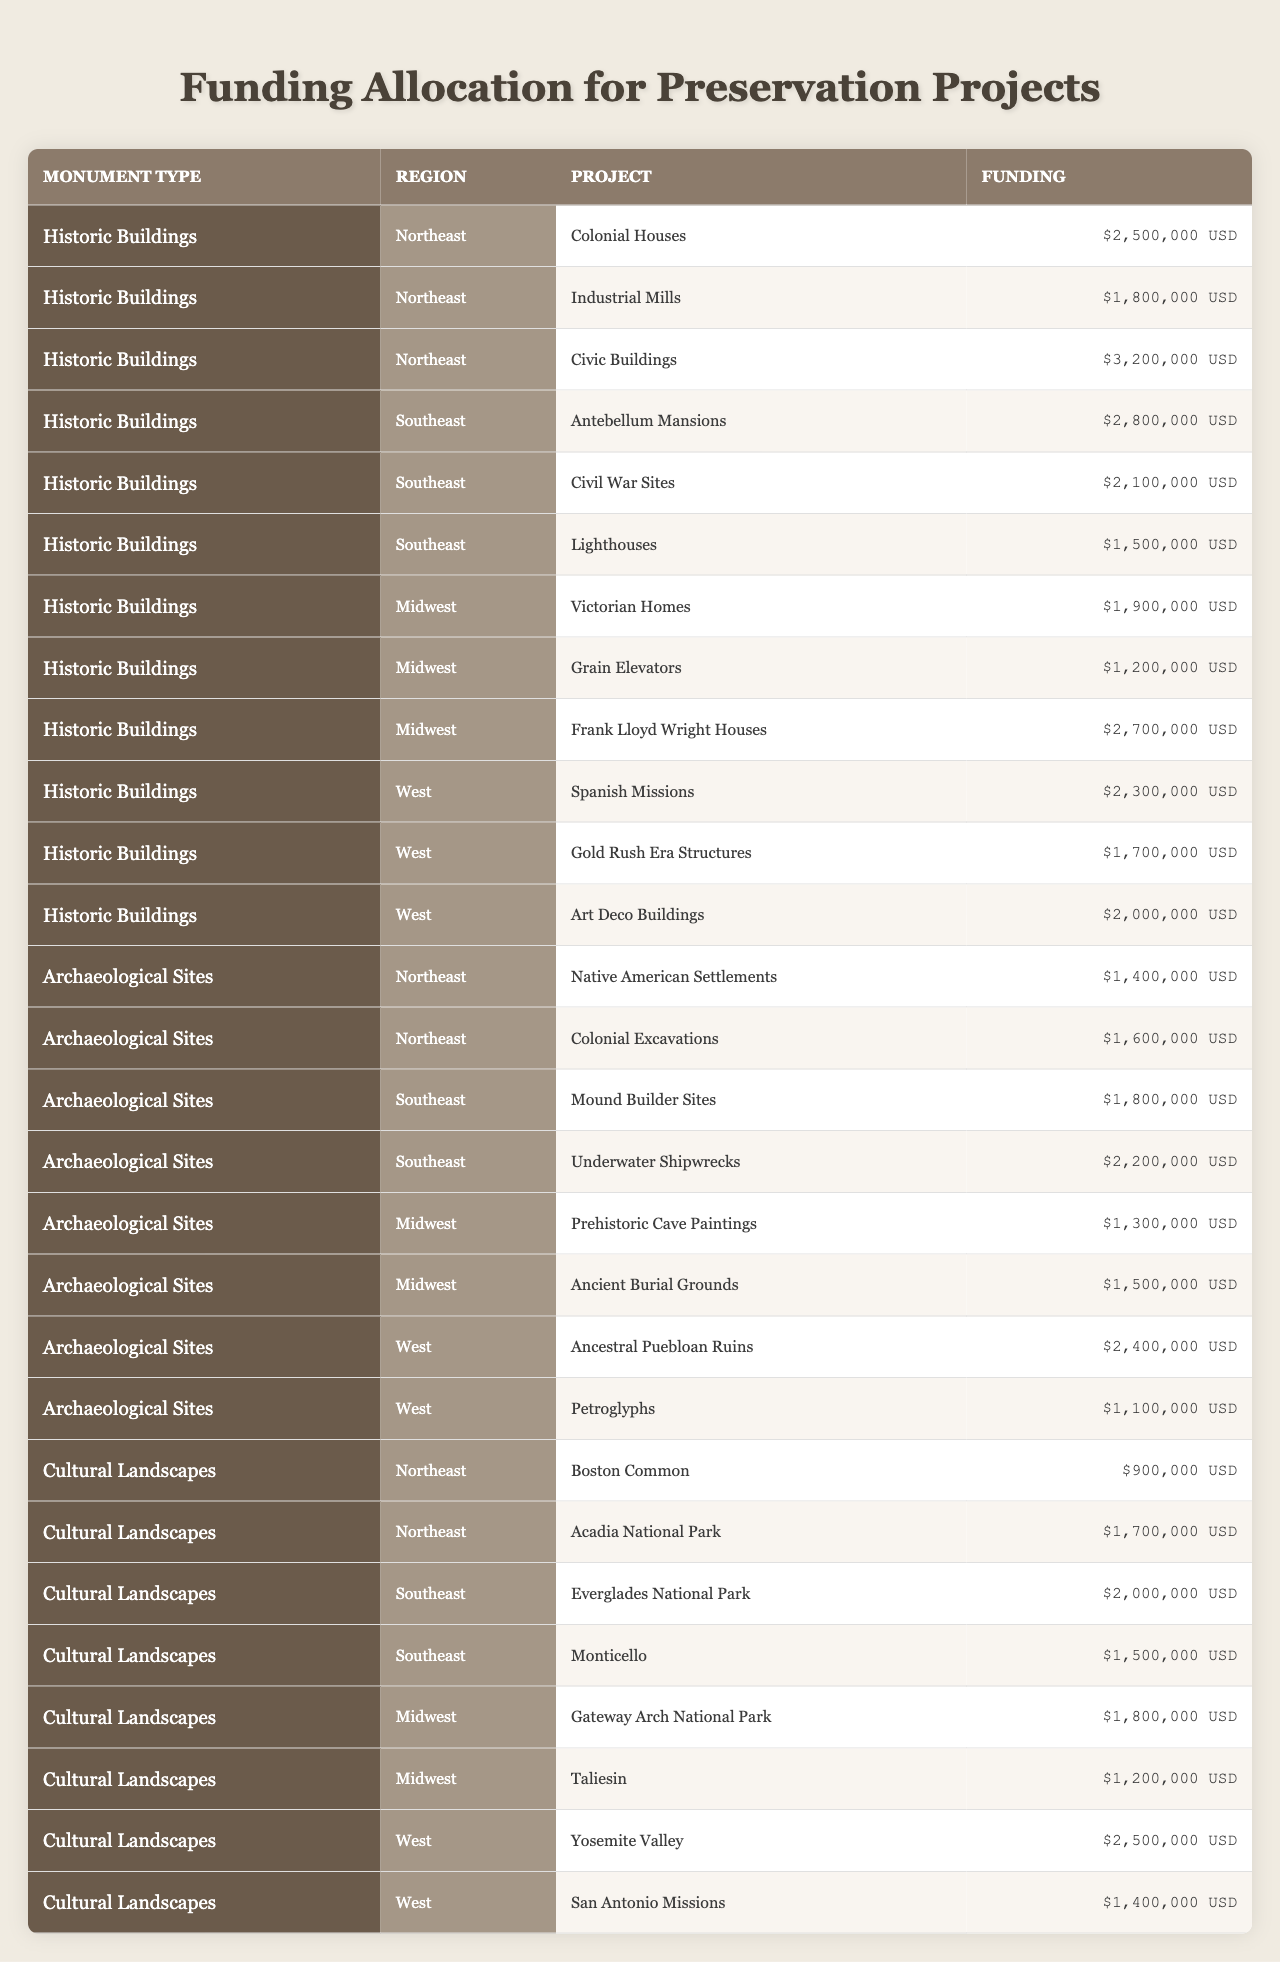What is the total funding allocated for all Historic Buildings in the Northeast region? The funding for Historic Buildings in the Northeast includes Colonial Houses ($2,500,000), Industrial Mills ($1,800,000), and Civic Buildings ($3,200,000). Adding these amounts gives $2,500,000 + $1,800,000 + $3,200,000 = $7,500,000.
Answer: $7,500,000 Which type of Archaeological Sites has the highest funding in the Southeast region? In the Southeast region for Archaeological Sites, funding is allocated as follows: Mound Builder Sites ($1,800,000) and Underwater Shipwrecks ($2,200,000). The highest funding is $2,200,000 for Underwater Shipwrecks.
Answer: Underwater Shipwrecks Is the total funding for Cultural Landscapes in the West greater than that in the Midwest? For the West region, Cultural Landscapes funding totals Yosemite Valley ($2,500,000) and San Antonio Missions ($1,400,000), giving $2,500,000 + $1,400,000 = $3,900,000. In the Midwest, Gateway Arch National Park ($1,800,000) and Taliesin ($1,200,000) sum to $3,000,000. Since $3,900,000 > $3,000,000, the statement is true.
Answer: Yes What is the average funding amount for Archaeological Sites across all regions? The total funding for Archaeological Sites is calculated by adding the funding of each region: Northeast ($1,400,000 + $1,600,000 = $3,000,000), Southeast ($1,800,000 + $2,200,000 = $4,000,000), Midwest ($1,300,000 + $1,500,000 = $2,800,000), and West ($2,400,000 + $1,100,000 = $3,500,000). This gives a total of $3,000,000 + $4,000,000 + $2,800,000 + $3,500,000 = $13,300,000, spread across 4 regions making the average $13,300,000 / 4 = $3,325,000.
Answer: $3,325,000 Which region has the least funding allocation for Cultural Landscapes? In the Northeast for Cultural Landscapes, funding is $900,000 for Boston Common and $1,700,000 for Acadia National Park totaling $2,600,000. In the Southeast, the total is $2,000,000; Midwest totals $3,000,000; and the West totals $3,900,000. The Northeast region with $2,600,000 has the least funding allocation for Cultural Landscapes.
Answer: Northeast How much more funding is allocated to Gold Rush Era Structures compared to Civil War Sites? Gold Rush Era Structures in the West are allocated $1,700,000, while Civil War Sites in the Southeast receive $2,100,000. The difference is calculated as $2,100,000 - $1,700,000 = $400,000, thus there is $400,000 more for Civil War Sites.
Answer: $400,000 Which monument type has the highest individual project funding in the Midwest region? In the Midwest, the funding amounts are Victorian Homes ($1,900,000), Grain Elevators ($1,200,000), Frank Lloyd Wright Houses ($2,700,000) for Historic Buildings, Prehistoric Cave Paintings ($1,300,000), and Ancient Burial Grounds ($1,500,000) for Archaeological Sites, and Gateway Arch National Park ($1,800,000) and Taliesin ($1,200,000) for Cultural Landscapes. The highest is $2,700,000 for Frank Lloyd Wright Houses.
Answer: Frank Lloyd Wright Houses What is the combined funding for Colonial Houses and Civic Buildings in the Northeast? The funding for Colonial Houses is $2,500,000 and for Civic Buildings is $3,200,000. The sum is calculated as $2,500,000 + $3,200,000 = $5,700,000.
Answer: $5,700,000 Is there any Archaeological Site in the West that is allocated less funding than the Petroglyphs? In the West, Ancestral Puebloan Ruins are funded at $2,400,000, while Petroglyphs are allocated $1,100,000. Ancestral Puebloan Ruins ($2,400,000) is higher than Petroglyphs ($1,100,000), thus the statement is false.
Answer: No 